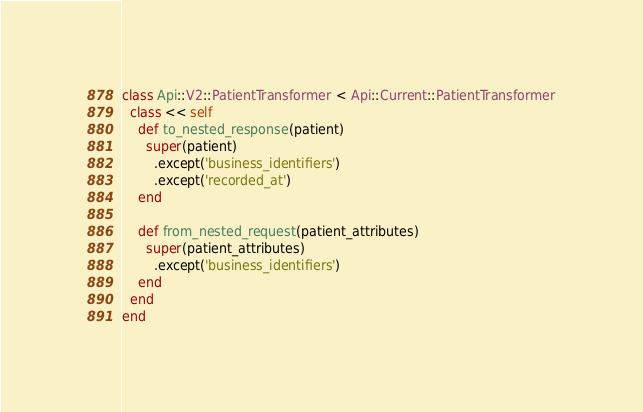<code> <loc_0><loc_0><loc_500><loc_500><_Ruby_>class Api::V2::PatientTransformer < Api::Current::PatientTransformer
  class << self
    def to_nested_response(patient)
      super(patient)
        .except('business_identifiers')
        .except('recorded_at')
    end

    def from_nested_request(patient_attributes)
      super(patient_attributes)
        .except('business_identifiers')
    end
  end
end
</code> 